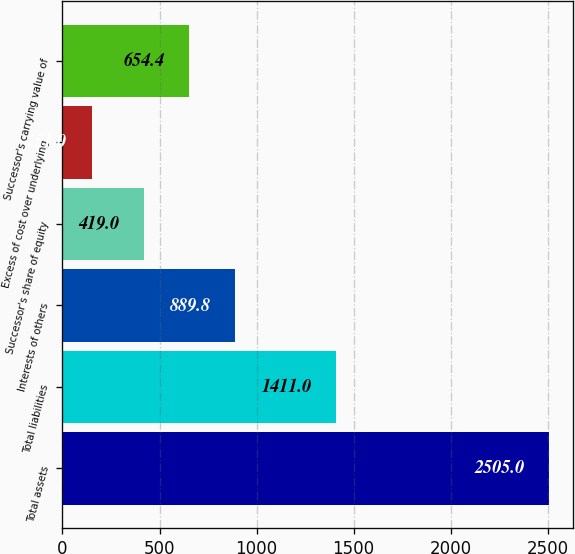<chart> <loc_0><loc_0><loc_500><loc_500><bar_chart><fcel>Total assets<fcel>Total liabilities<fcel>Interests of others<fcel>Successor's share of equity<fcel>Excess of cost over underlying<fcel>Successor's carrying value of<nl><fcel>2505<fcel>1411<fcel>889.8<fcel>419<fcel>151<fcel>654.4<nl></chart> 